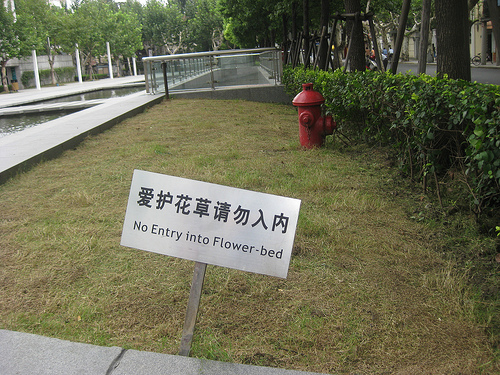<image>
Is the sign on the grass? Yes. Looking at the image, I can see the sign is positioned on top of the grass, with the grass providing support. 